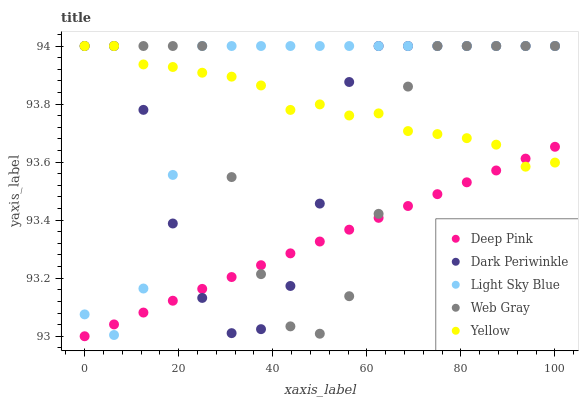Does Deep Pink have the minimum area under the curve?
Answer yes or no. Yes. Does Light Sky Blue have the maximum area under the curve?
Answer yes or no. Yes. Does Web Gray have the minimum area under the curve?
Answer yes or no. No. Does Web Gray have the maximum area under the curve?
Answer yes or no. No. Is Deep Pink the smoothest?
Answer yes or no. Yes. Is Web Gray the roughest?
Answer yes or no. Yes. Is Web Gray the smoothest?
Answer yes or no. No. Is Deep Pink the roughest?
Answer yes or no. No. Does Deep Pink have the lowest value?
Answer yes or no. Yes. Does Web Gray have the lowest value?
Answer yes or no. No. Does Light Sky Blue have the highest value?
Answer yes or no. Yes. Does Deep Pink have the highest value?
Answer yes or no. No. Does Light Sky Blue intersect Deep Pink?
Answer yes or no. Yes. Is Light Sky Blue less than Deep Pink?
Answer yes or no. No. Is Light Sky Blue greater than Deep Pink?
Answer yes or no. No. 